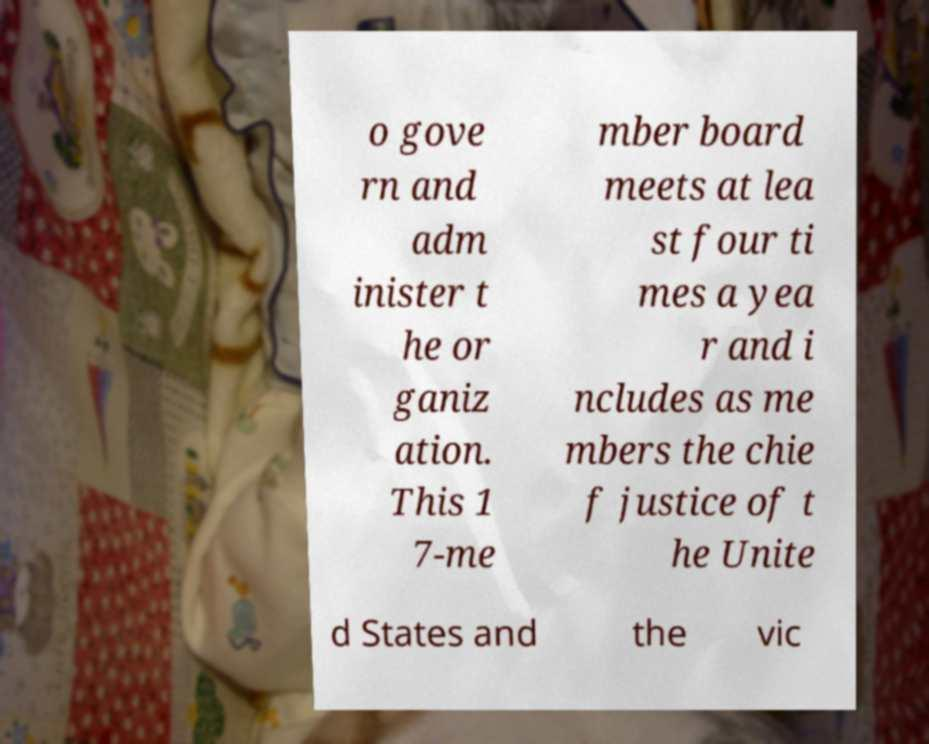Please read and relay the text visible in this image. What does it say? o gove rn and adm inister t he or ganiz ation. This 1 7-me mber board meets at lea st four ti mes a yea r and i ncludes as me mbers the chie f justice of t he Unite d States and the vic 